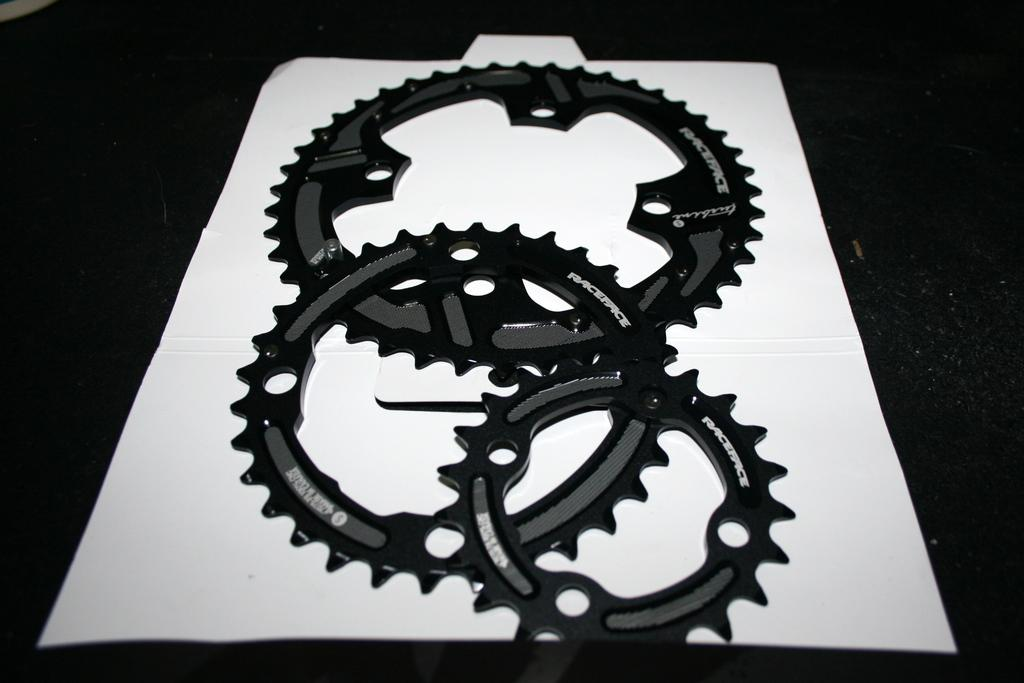What objects are present in the image related to vehicles? There are hubcaps in the image. What is on the table in the image? There is a paper on the table in the image. How many jellyfish are swimming in the paper on the table? There are no jellyfish present in the image; the paper on the table does not depict any marine life. 